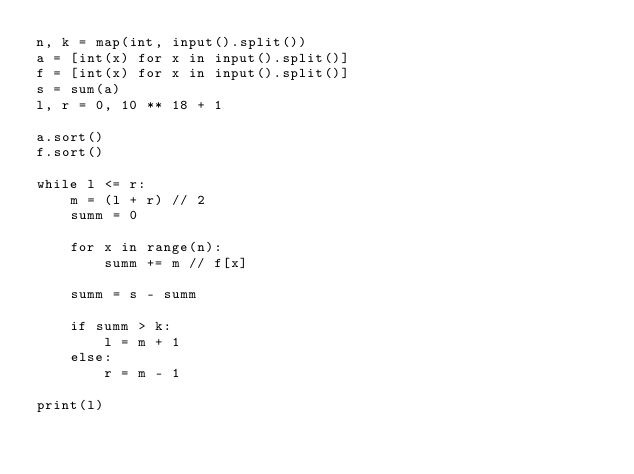<code> <loc_0><loc_0><loc_500><loc_500><_Python_>n, k = map(int, input().split())
a = [int(x) for x in input().split()]
f = [int(x) for x in input().split()]
s = sum(a)
l, r = 0, 10 ** 18 + 1

a.sort()
f.sort()

while l <= r:
    m = (l + r) // 2
    summ = 0

    for x in range(n):
        summ += m // f[x]

    summ = s - summ

    if summ > k:
        l = m + 1
    else:
        r = m - 1

print(l)</code> 